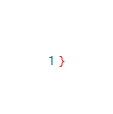<code> <loc_0><loc_0><loc_500><loc_500><_CSS_>}
</code> 